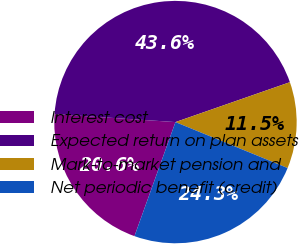Convert chart. <chart><loc_0><loc_0><loc_500><loc_500><pie_chart><fcel>Interest cost<fcel>Expected return on plan assets<fcel>Mark-to-market pension and<fcel>Net periodic benefit (credit)<nl><fcel>20.56%<fcel>43.61%<fcel>11.53%<fcel>24.3%<nl></chart> 